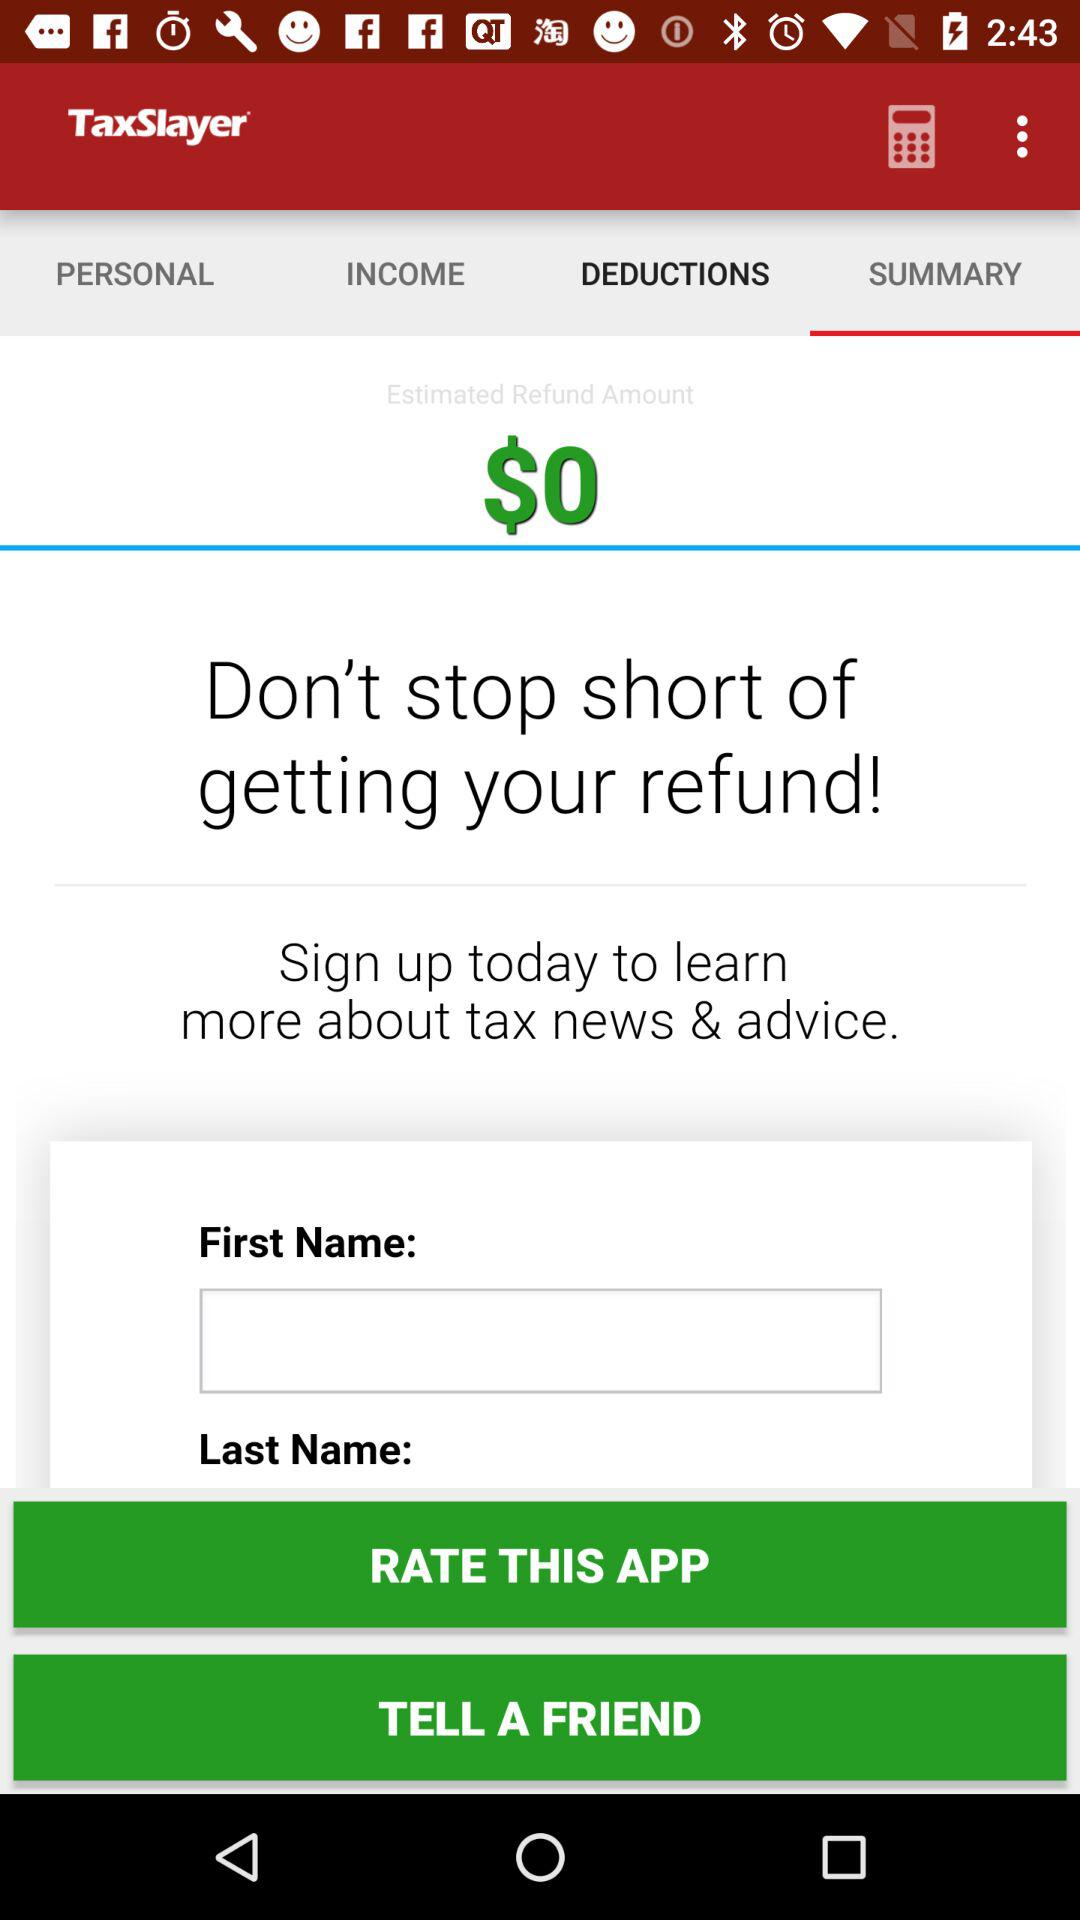Which option is selected in TaxSlayer? The selected option is "SUMMARY". 